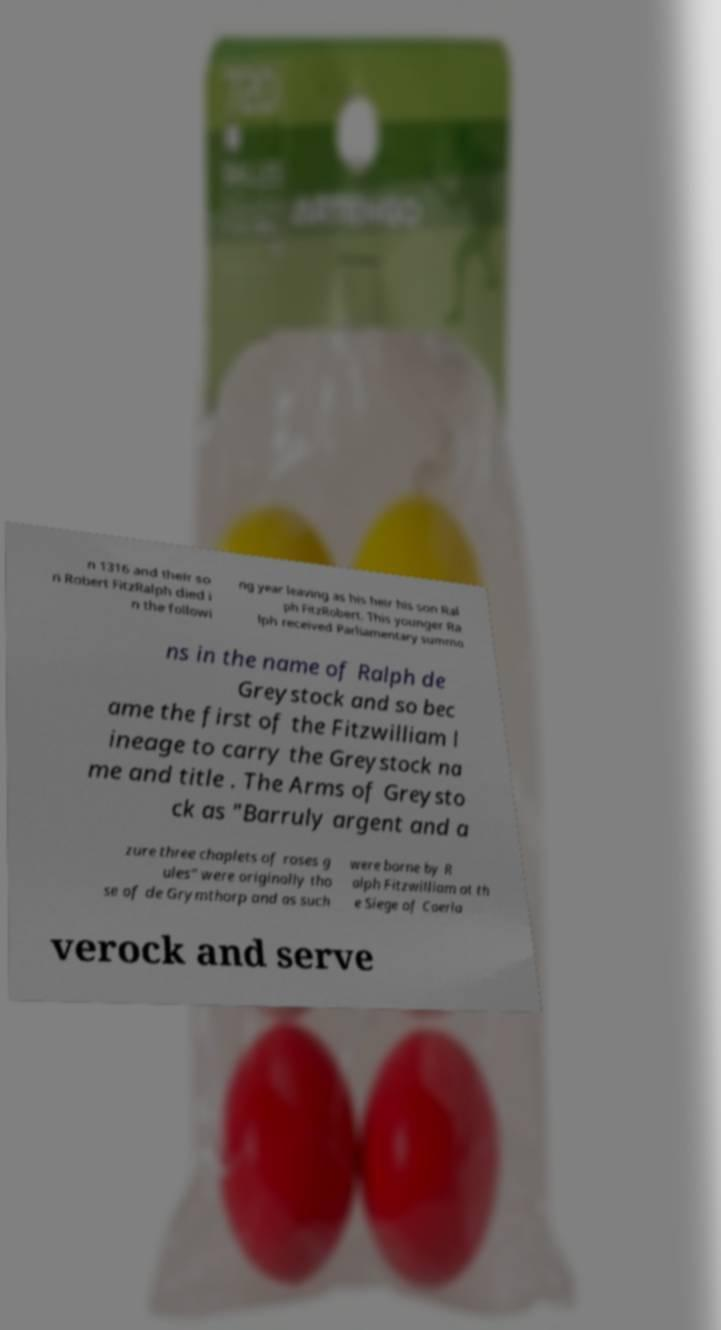Please read and relay the text visible in this image. What does it say? n 1316 and their so n Robert FitzRalph died i n the followi ng year leaving as his heir his son Ral ph FitzRobert. This younger Ra lph received Parliamentary summo ns in the name of Ralph de Greystock and so bec ame the first of the Fitzwilliam l ineage to carry the Greystock na me and title . The Arms of Greysto ck as "Barruly argent and a zure three chaplets of roses g ules" were originally tho se of de Grymthorp and as such were borne by R alph Fitzwilliam at th e Siege of Caerla verock and serve 